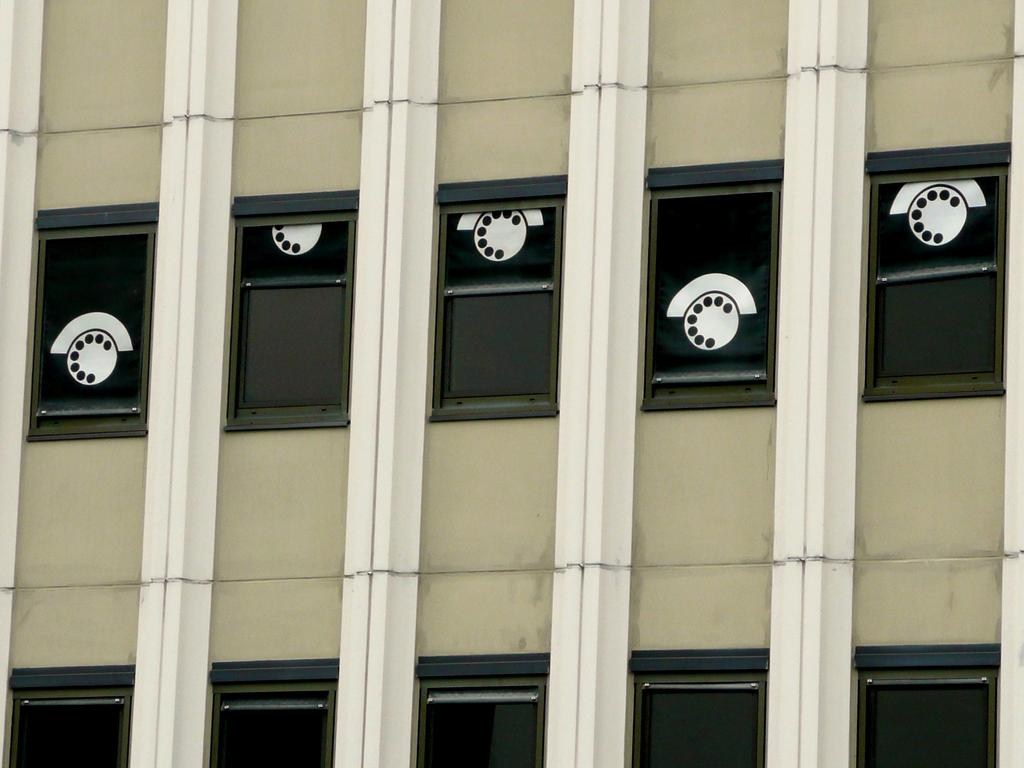What is the main subject of the image? The main subject of the image is a building. What can be seen on the building? The building has different pictures on it. What color is the building? The building is green in color. What type of brass instrument is being played in the image? There is no brass instrument or any indication of music being played in the image; it features a building with pictures on it. 